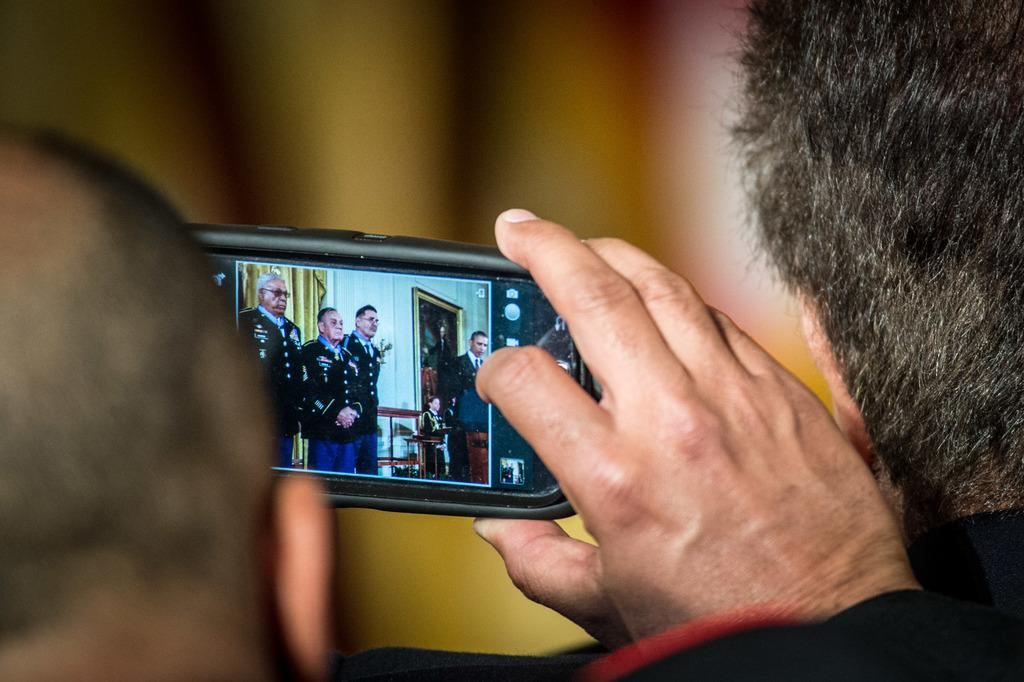Who is the main subject in the image? There is a man in the image. What is the man doing in the image? The man is capturing a photo or video using his mobile. Can you identify any other notable person in the image? Yes, Obama is present in the image. How many other men are in the image besides the man capturing the photo or video? There are other men in the image. Can you see a snail crawling on Obama's neck in the image? No, there is no snail present in the image, nor is there any snail crawling on Obama's neck. 